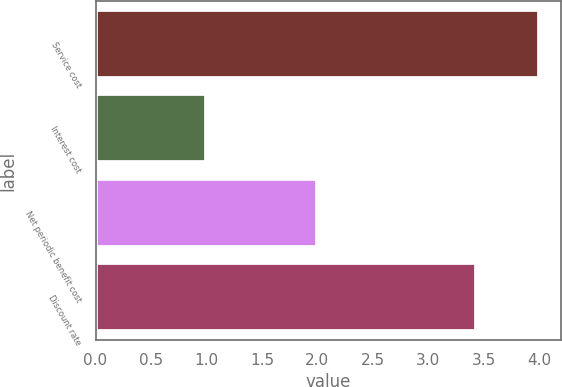Convert chart to OTSL. <chart><loc_0><loc_0><loc_500><loc_500><bar_chart><fcel>Service cost<fcel>Interest cost<fcel>Net periodic benefit cost<fcel>Discount rate<nl><fcel>4<fcel>1<fcel>2<fcel>3.43<nl></chart> 